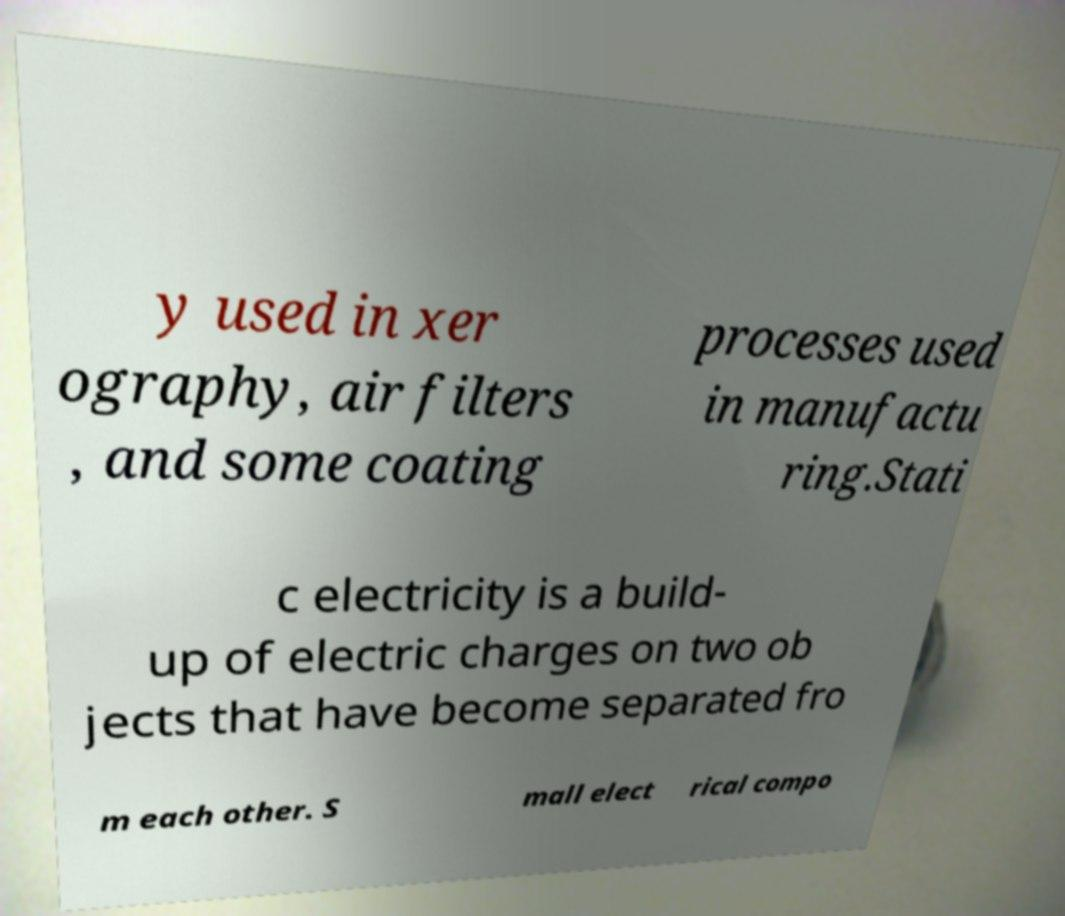Can you read and provide the text displayed in the image?This photo seems to have some interesting text. Can you extract and type it out for me? y used in xer ography, air filters , and some coating processes used in manufactu ring.Stati c electricity is a build- up of electric charges on two ob jects that have become separated fro m each other. S mall elect rical compo 